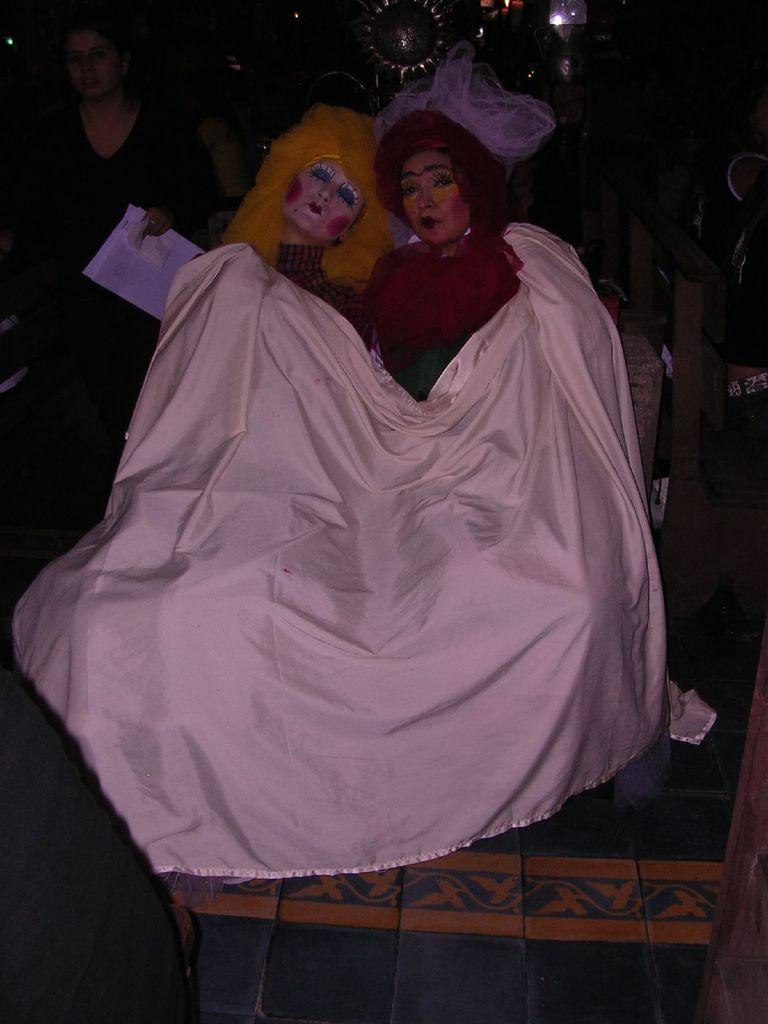How many dolls are present in the image? There are two dolls in the image. Where are the dolls located in relation to the image? The dolls are placed in the front. What is the dolls resting on in the image? The dolls are on a white cloth. What can be observed about the background of the image? There is a dark background in the image. What type of soda is being served by the dolls in the image? There is no soda present in the image. The image only features two dolls placed on a white cloth with a dark background. 